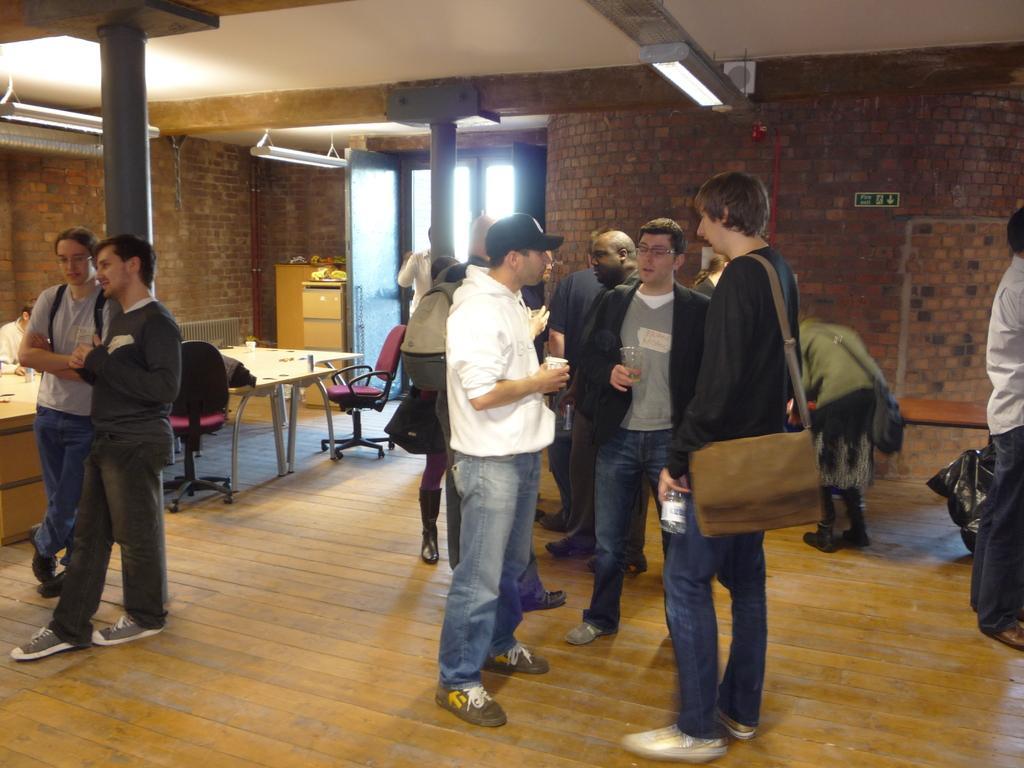How would you summarize this image in a sentence or two? In this image we can see group of persons and among them few people are holding objects. Behind the persons we can see pillars, wall, doors, chairs and table. There are few objects on the tables. At the top we can see the roof and the lights. 